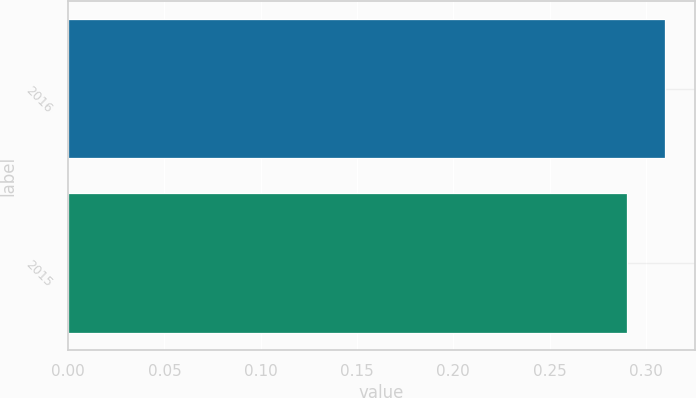<chart> <loc_0><loc_0><loc_500><loc_500><bar_chart><fcel>2016<fcel>2015<nl><fcel>0.31<fcel>0.29<nl></chart> 